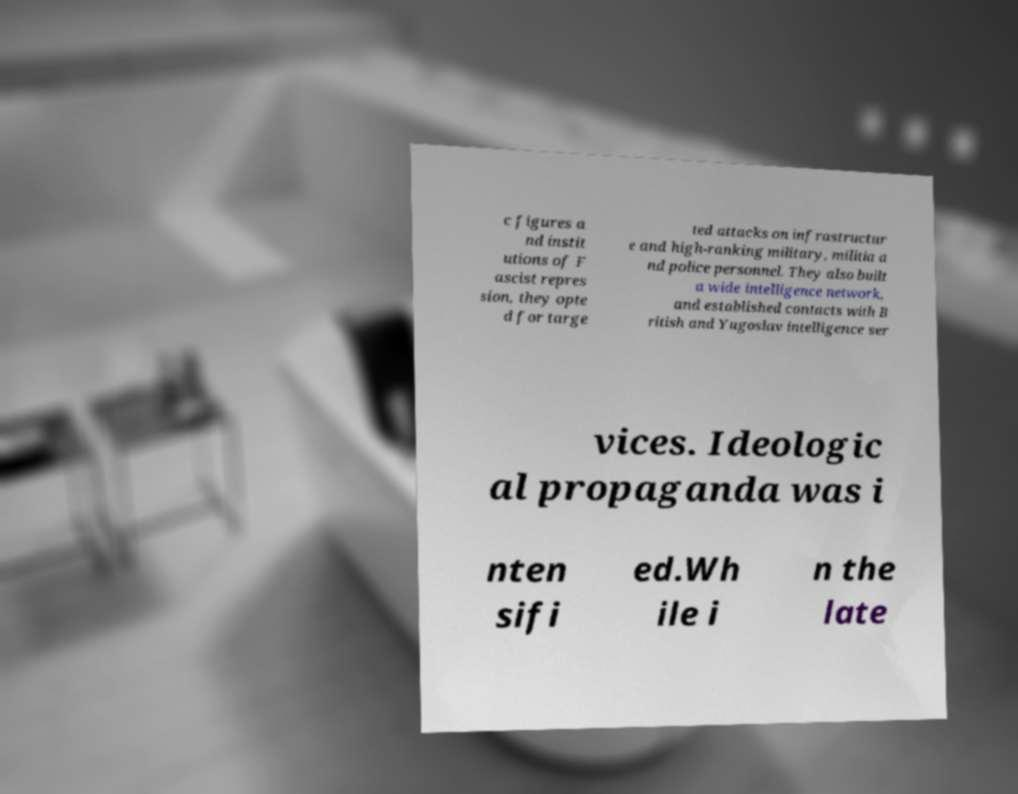What messages or text are displayed in this image? I need them in a readable, typed format. c figures a nd instit utions of F ascist repres sion, they opte d for targe ted attacks on infrastructur e and high-ranking military, militia a nd police personnel. They also built a wide intelligence network, and established contacts with B ritish and Yugoslav intelligence ser vices. Ideologic al propaganda was i nten sifi ed.Wh ile i n the late 